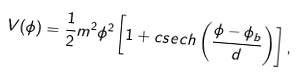<formula> <loc_0><loc_0><loc_500><loc_500>V ( \phi ) = \frac { 1 } { 2 } m ^ { 2 } \phi ^ { 2 } \left [ 1 + c s e c h \left ( \frac { \phi - \phi _ { b } } { d } \right ) \right ] ,</formula> 